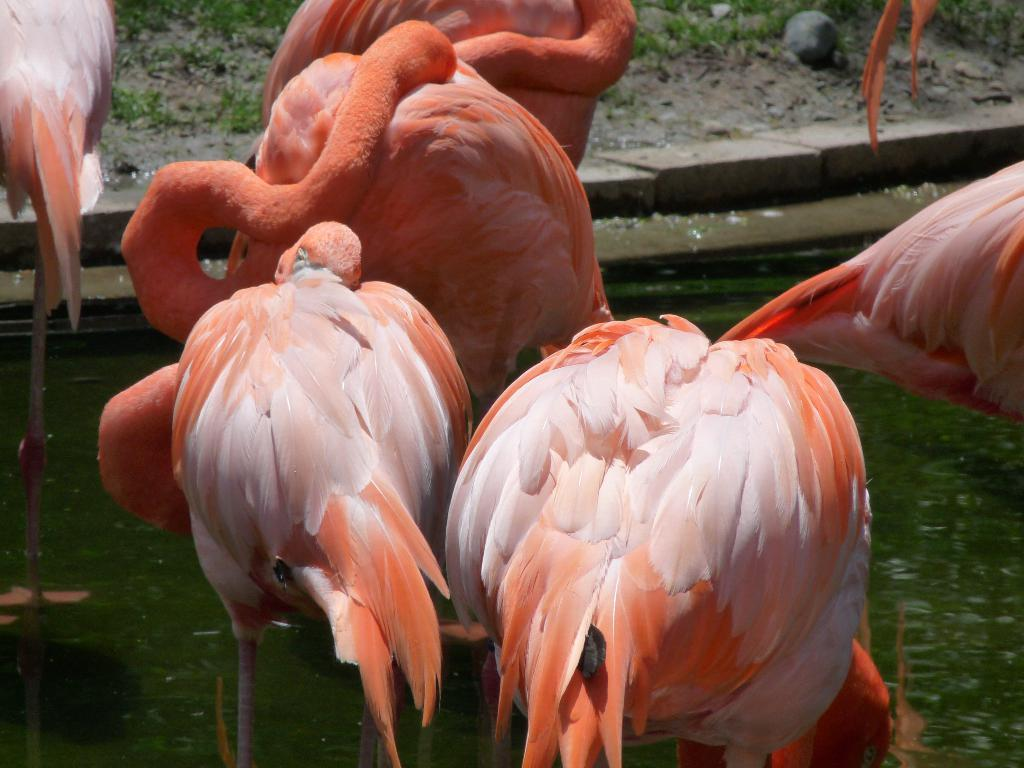What type of animals are in the image? There is a group of flamingo birds in the image. What is the primary element in which the flamingos are situated? The flamingos are situated in water. What type of vegetation is visible in the image? There is grass visible in the image. What type of adjustment can be seen on the flamingos' wings in the image? There is no adjustment visible on the flamingos' wings in the image. Is there a road visible in the image? No, there is no road visible in the image. 